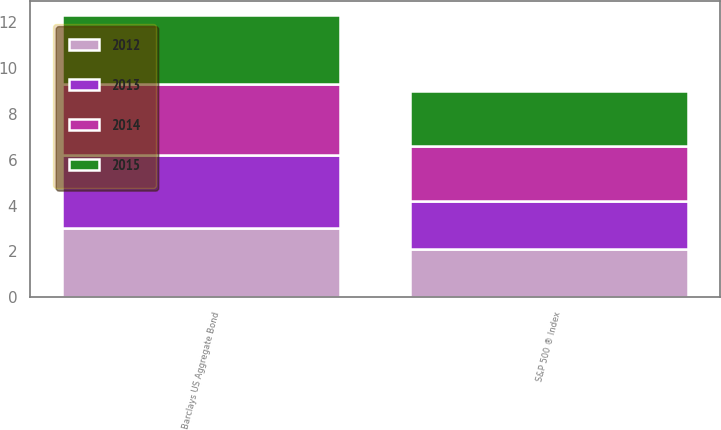Convert chart. <chart><loc_0><loc_0><loc_500><loc_500><stacked_bar_chart><ecel><fcel>Barclays US Aggregate Bond<fcel>S&P 500 ® Index<nl><fcel>2015<fcel>3<fcel>2.4<nl><fcel>2012<fcel>3<fcel>2.1<nl><fcel>2013<fcel>3.2<fcel>2.1<nl><fcel>2014<fcel>3.1<fcel>2.4<nl></chart> 